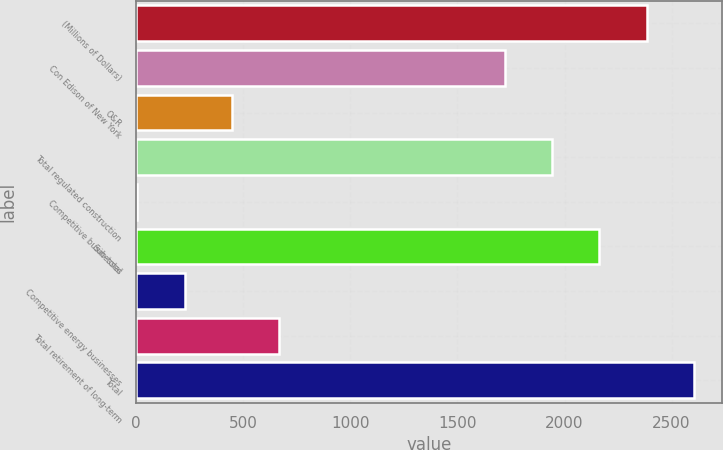Convert chart to OTSL. <chart><loc_0><loc_0><loc_500><loc_500><bar_chart><fcel>(Millions of Dollars)<fcel>Con Edison of New York<fcel>O&R<fcel>Total regulated construction<fcel>Competitive businesses<fcel>Sub-total<fcel>Competitive energy businesses<fcel>Total retirement of long-term<fcel>Total<nl><fcel>2383.8<fcel>1722<fcel>447.2<fcel>1942.6<fcel>6<fcel>2163.2<fcel>226.6<fcel>667.8<fcel>2604.4<nl></chart> 